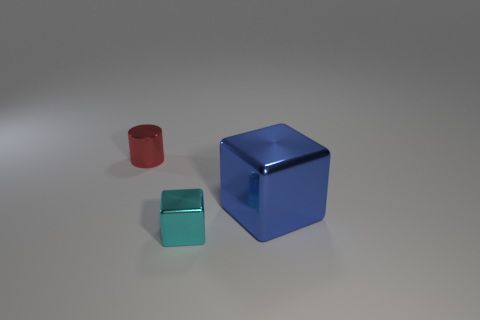Add 2 metallic cylinders. How many objects exist? 5 Subtract all cubes. How many objects are left? 1 Add 3 blue shiny blocks. How many blue shiny blocks exist? 4 Subtract 0 gray cubes. How many objects are left? 3 Subtract all small cyan metallic cubes. Subtract all large red cubes. How many objects are left? 2 Add 1 small shiny blocks. How many small shiny blocks are left? 2 